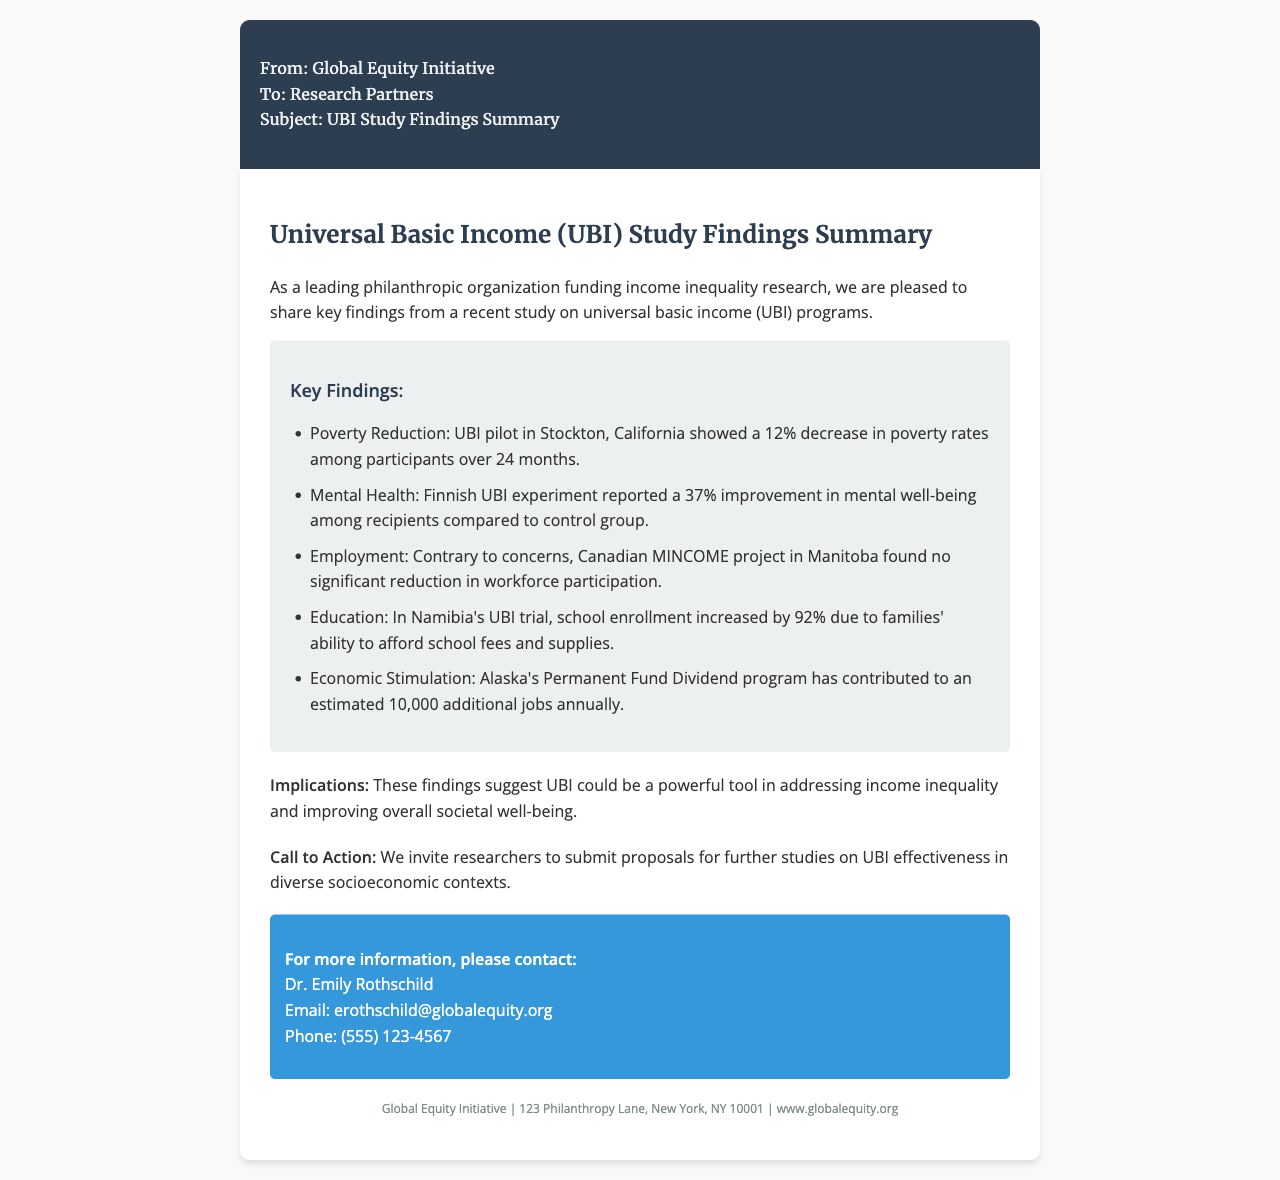What was the percentage decrease in poverty rates in Stockton's UBI pilot? The document states that there was a 12% decrease in poverty rates among participants over 24 months in Stockton, California.
Answer: 12% What improvement in mental well-being was reported in the Finnish UBI experiment? The document indicates a 37% improvement in mental well-being among recipients compared to the control group.
Answer: 37% What significant change in school enrollment was observed in Namibia's UBI trial? According to the document, school enrollment increased by 92% due to families' ability to afford school fees and supplies.
Answer: 92% Which UBI program is mentioned as contributing to an estimated additional number of jobs annually? The document refers to Alaska's Permanent Fund Dividend program contributing to an estimated 10,000 additional jobs annually.
Answer: 10,000 What is the purpose of the call to action in the document? The document invites researchers to submit proposals for further studies on UBI effectiveness in diverse socioeconomic contexts.
Answer: Submit proposals for further studies Who should be contacted for more information regarding the UBI study findings? The document specifies Dr. Emily Rothschild as the contact for more information.
Answer: Dr. Emily Rothschild 